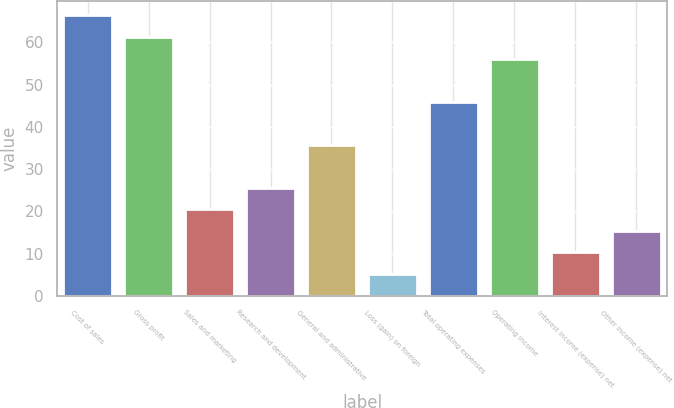Convert chart to OTSL. <chart><loc_0><loc_0><loc_500><loc_500><bar_chart><fcel>Cost of sales<fcel>Gross profit<fcel>Sales and marketing<fcel>Research and development<fcel>General and administrative<fcel>Loss (gain) on foreign<fcel>Total operating expenses<fcel>Operating income<fcel>Interest income (expense) net<fcel>Other income (expense) net<nl><fcel>66.4<fcel>61.3<fcel>20.5<fcel>25.6<fcel>35.8<fcel>5.2<fcel>46<fcel>56.2<fcel>10.3<fcel>15.4<nl></chart> 